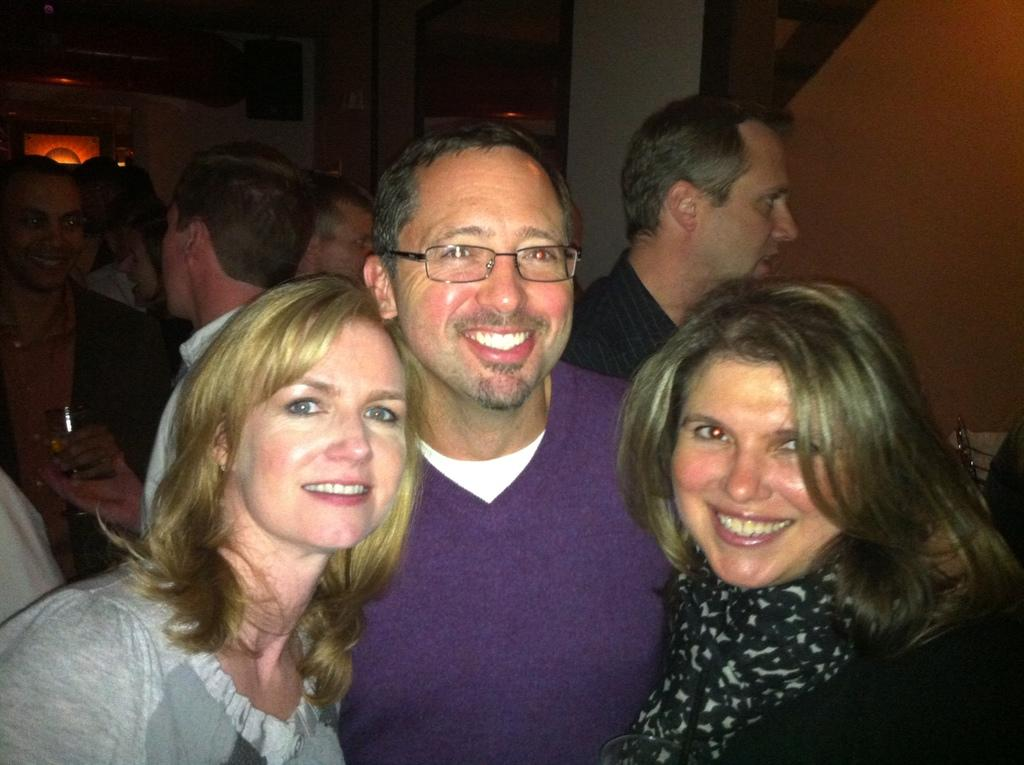How many people are visible in the image? There is a man and two women in the image, making a total of three people. Are there any other individuals present in the image? Yes, there are other people in the background of the image. Can you describe the overall lighting in the image? The rest of the image is dark, with the exception of the people mentioned. What type of quill is being used by the man in the image? There is no quill present in the image. What route are the women taking in the image? The image does not show the women taking any route, as it is a still image. 